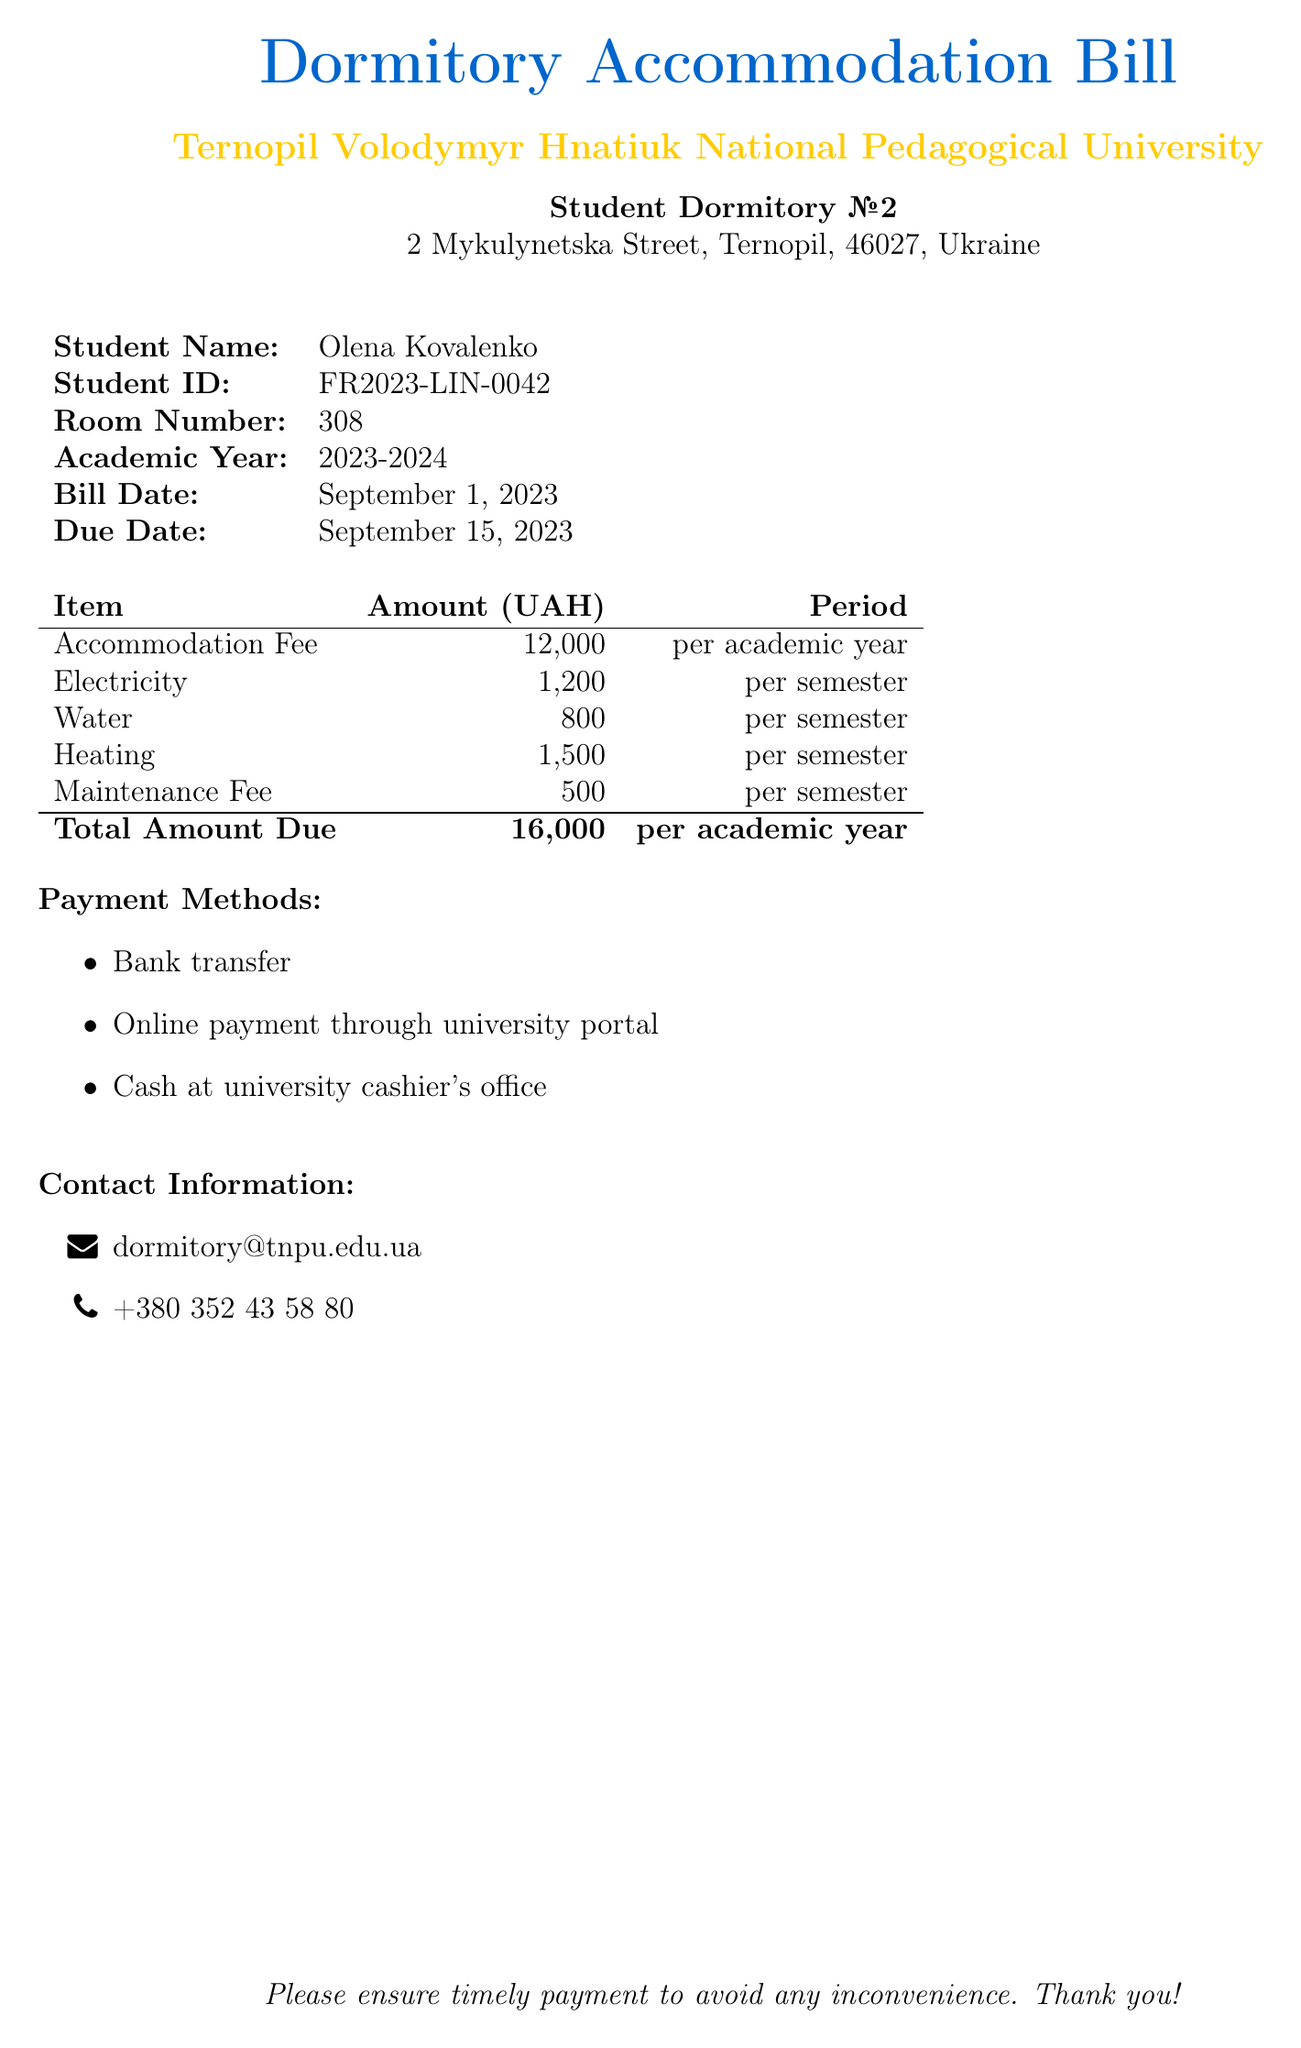What is the name of the student? The student name is listed at the top of the document.
Answer: Olena Kovalenko What is the total amount due? The total amount due is summarized in the table at the bottom of the document.
Answer: 16,000 What is the room number? The room number for the student is indicated in the student information section.
Answer: 308 What utilities are included in the bill? The bill lists specific utilities with their associated fees, detailing which are included.
Answer: Electricity, Water, Heating When is the bill due? The due date is specified clearly in the document.
Answer: September 15, 2023 How much is the maintenance fee? The maintenance fee is outlined in the itemized list of charges in the document.
Answer: 500 What payment method is not listed? This question checks for a method that is not in the provided section.
Answer: Check What is the accommodation fee for the academic year? The accommodation fee is specified in the itemized list under the relevant category.
Answer: 12,000 What semester do the utility fees apply to? The utility fees are listed with their applicable periods stated in the table.
Answer: per semester 